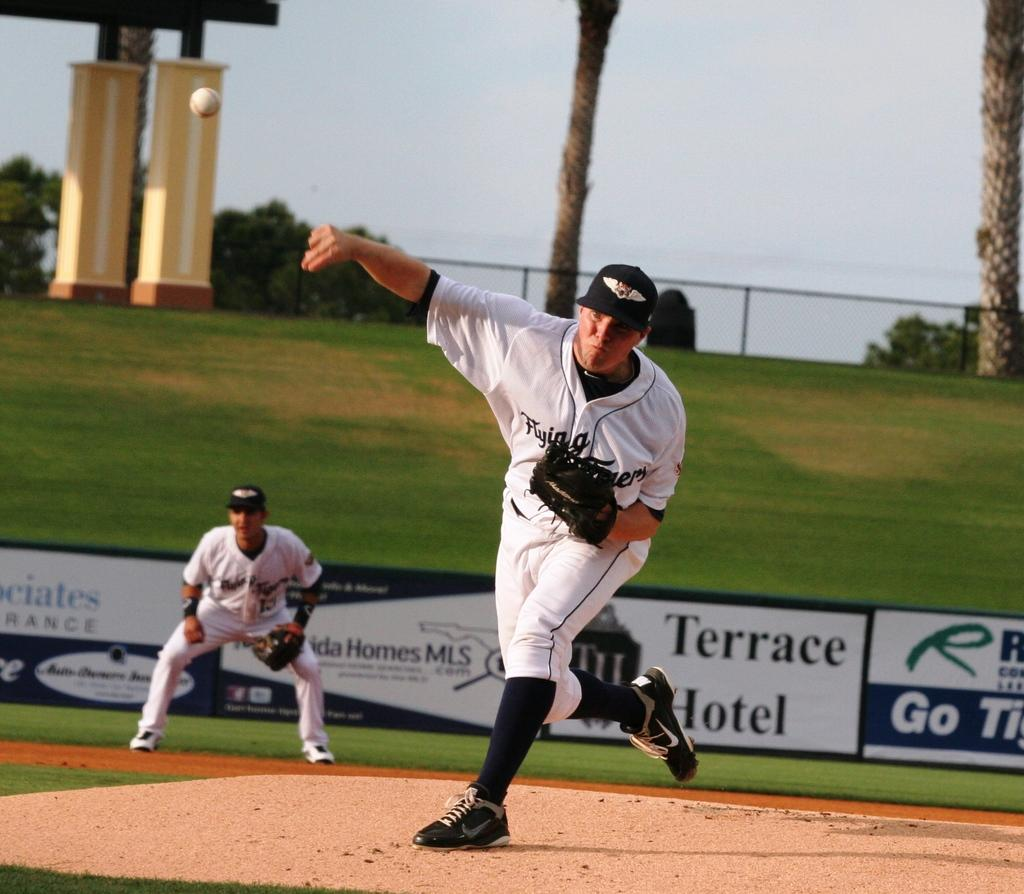<image>
Create a compact narrative representing the image presented. A man throwing a ball on a field sponsored by Terrace Hotel. 